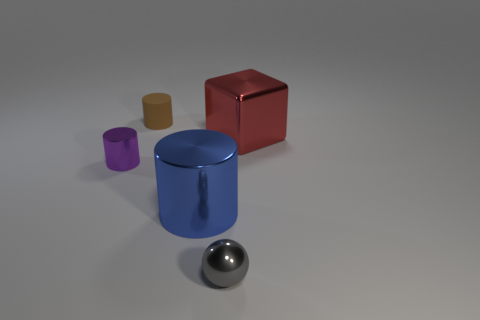How could the lighting of this scene affect the perception of the objects? The lighting in this scene appears to be coming from above, casting soft shadows beneath the objects. This helps define the dimensions and textures of the objects and also affects the perception of their colors. The reflective sphere in particular shows strong highlights, indicating the direction and intensity of the light source. 